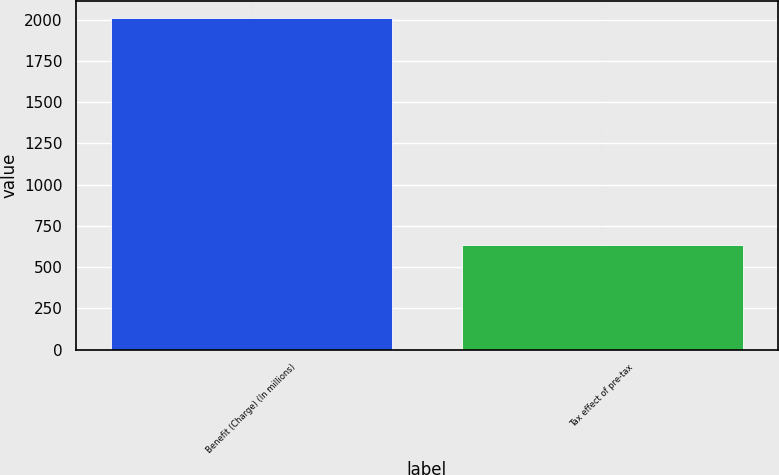Convert chart to OTSL. <chart><loc_0><loc_0><loc_500><loc_500><bar_chart><fcel>Benefit (Charge) (In millions)<fcel>Tax effect of pre-tax<nl><fcel>2012<fcel>636<nl></chart> 